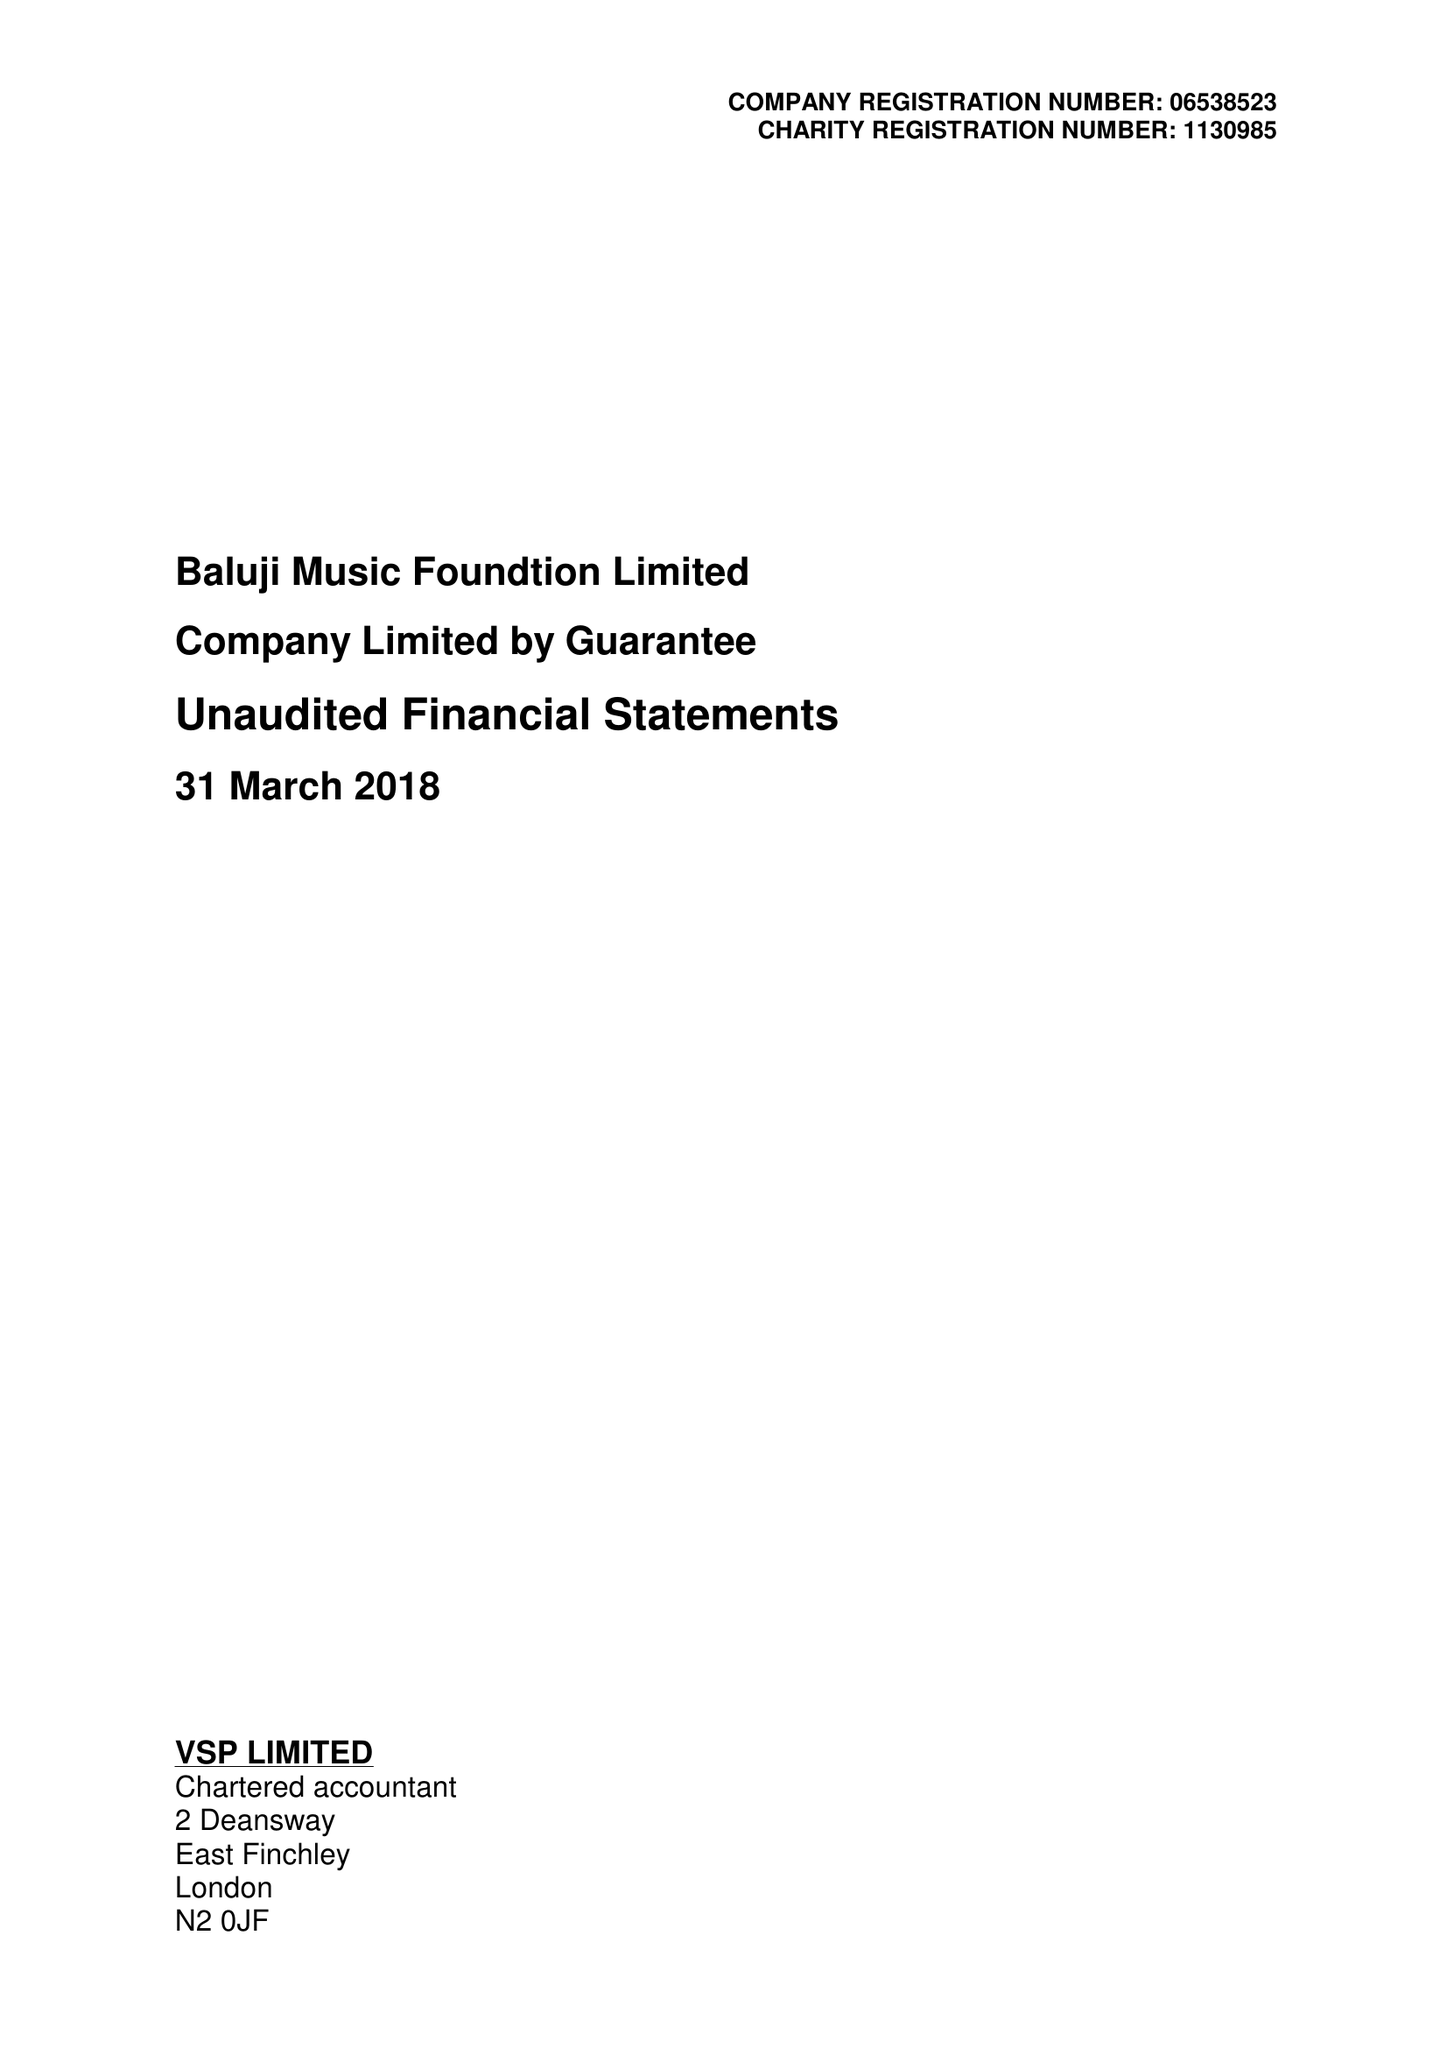What is the value for the address__street_line?
Answer the question using a single word or phrase. 33 NORTHOLME ROAD 